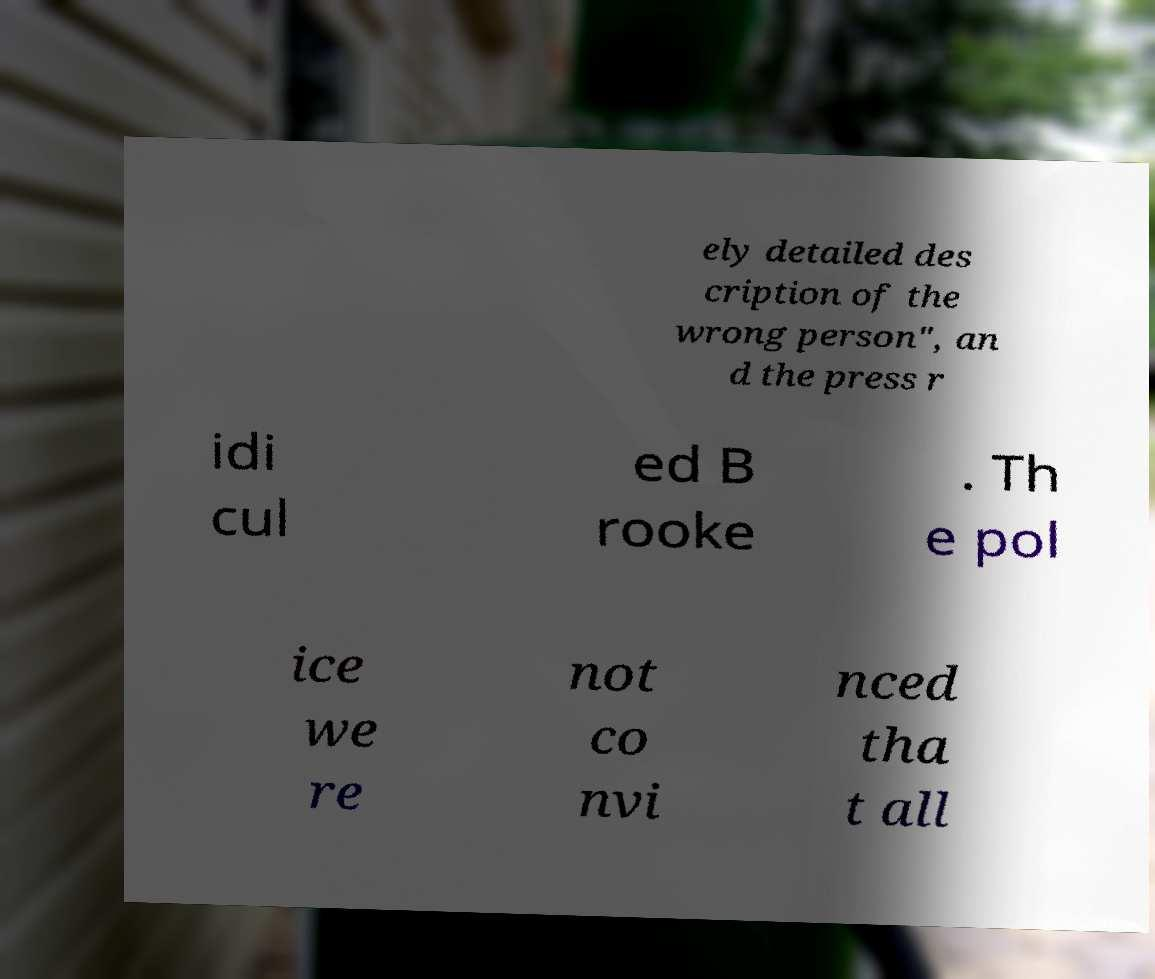There's text embedded in this image that I need extracted. Can you transcribe it verbatim? ely detailed des cription of the wrong person", an d the press r idi cul ed B rooke . Th e pol ice we re not co nvi nced tha t all 